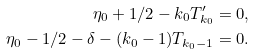<formula> <loc_0><loc_0><loc_500><loc_500>\eta _ { 0 } + 1 / 2 - k _ { 0 } T _ { k _ { 0 } } ^ { \prime } = 0 , \\ \eta _ { 0 } - 1 / 2 - \delta - ( k _ { 0 } - 1 ) T _ { k _ { 0 } - 1 } = 0 .</formula> 